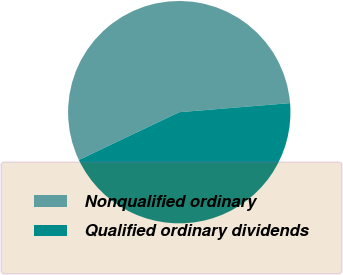<chart> <loc_0><loc_0><loc_500><loc_500><pie_chart><fcel>Nonqualified ordinary<fcel>Qualified ordinary dividends<nl><fcel>55.77%<fcel>44.23%<nl></chart> 